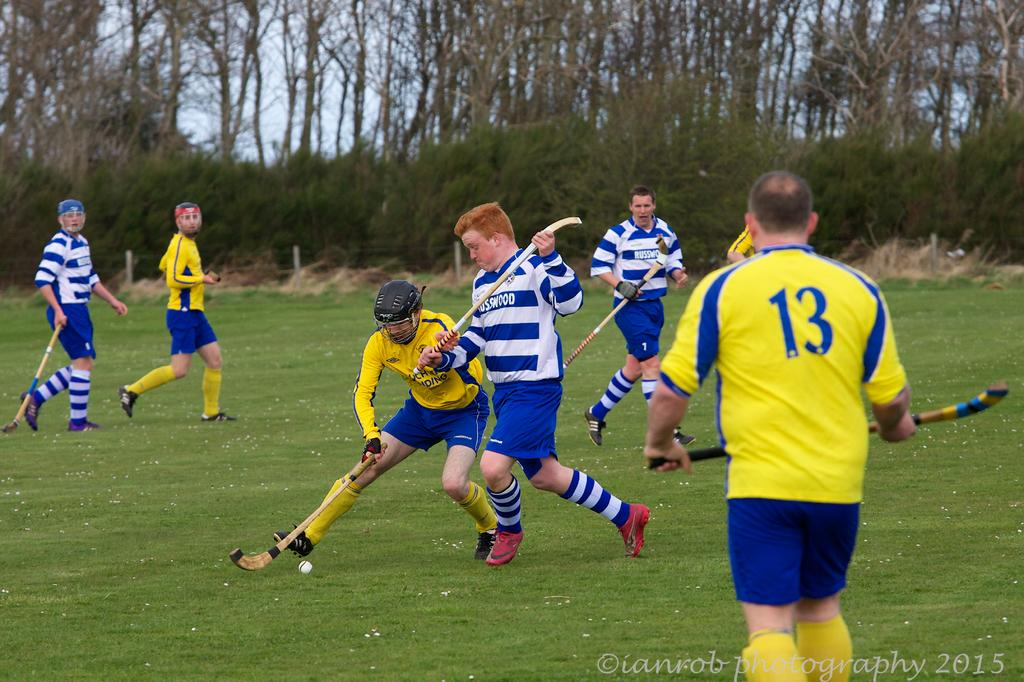<image>
Create a compact narrative representing the image presented. A group of field hockey players from Russwood play an opposing team. 